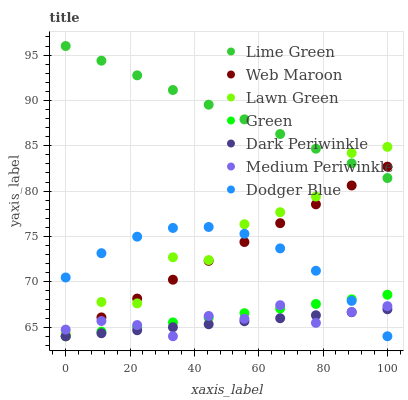Does Dark Periwinkle have the minimum area under the curve?
Answer yes or no. Yes. Does Lime Green have the maximum area under the curve?
Answer yes or no. Yes. Does Medium Periwinkle have the minimum area under the curve?
Answer yes or no. No. Does Medium Periwinkle have the maximum area under the curve?
Answer yes or no. No. Is Green the smoothest?
Answer yes or no. Yes. Is Lawn Green the roughest?
Answer yes or no. Yes. Is Medium Periwinkle the smoothest?
Answer yes or no. No. Is Medium Periwinkle the roughest?
Answer yes or no. No. Does Medium Periwinkle have the lowest value?
Answer yes or no. Yes. Does Lime Green have the lowest value?
Answer yes or no. No. Does Lime Green have the highest value?
Answer yes or no. Yes. Does Medium Periwinkle have the highest value?
Answer yes or no. No. Is Dark Periwinkle less than Lawn Green?
Answer yes or no. Yes. Is Lime Green greater than Dodger Blue?
Answer yes or no. Yes. Does Dark Periwinkle intersect Green?
Answer yes or no. Yes. Is Dark Periwinkle less than Green?
Answer yes or no. No. Is Dark Periwinkle greater than Green?
Answer yes or no. No. Does Dark Periwinkle intersect Lawn Green?
Answer yes or no. No. 